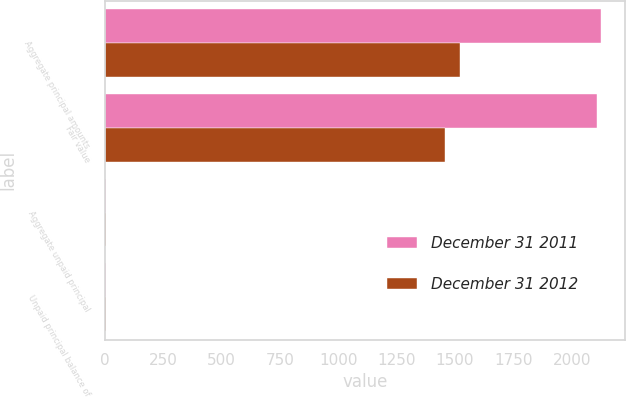Convert chart to OTSL. <chart><loc_0><loc_0><loc_500><loc_500><stacked_bar_chart><ecel><fcel>Aggregate principal amounts<fcel>Fair value<fcel>Aggregate unpaid principal<fcel>Unpaid principal balance of<nl><fcel>December 31 2011<fcel>2124<fcel>2110<fcel>4<fcel>4<nl><fcel>December 31 2012<fcel>1522<fcel>1459<fcel>4<fcel>4<nl></chart> 